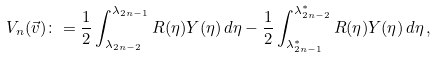Convert formula to latex. <formula><loc_0><loc_0><loc_500><loc_500>V _ { n } ( \vec { v } ) \colon = \frac { 1 } { 2 } \int _ { \lambda _ { 2 n - 2 } } ^ { \lambda _ { 2 n - 1 } } R ( \eta ) Y ( \eta ) \, d \eta - \frac { 1 } { 2 } \int _ { \lambda _ { 2 n - 1 } ^ { * } } ^ { \lambda _ { 2 n - 2 } ^ { * } } R ( \eta ) Y ( \eta ) \, d \eta \, ,</formula> 